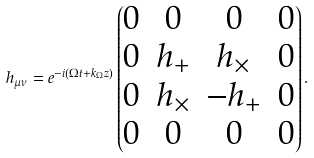<formula> <loc_0><loc_0><loc_500><loc_500>h _ { \mu \nu } = e ^ { - i ( \Omega t + k _ { \Omega } z ) } \begin{pmatrix} 0 & 0 & 0 & 0 \\ 0 & h _ { + } & h _ { \times } & 0 \\ 0 & h _ { \times } & - h _ { + } & 0 \\ 0 & 0 & 0 & 0 \\ \end{pmatrix} .</formula> 